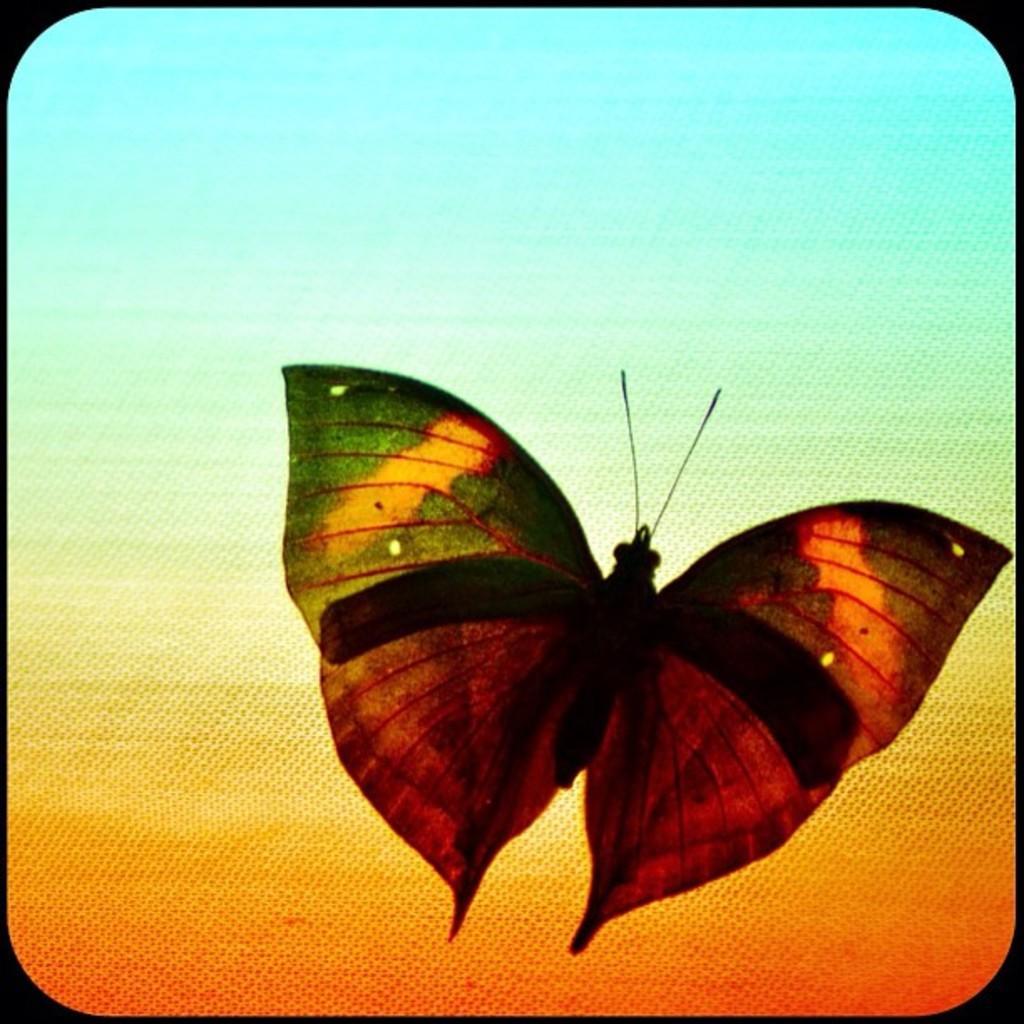Can you describe this image briefly? In the image I can see a butterfly. The butterfly is in different colors. 